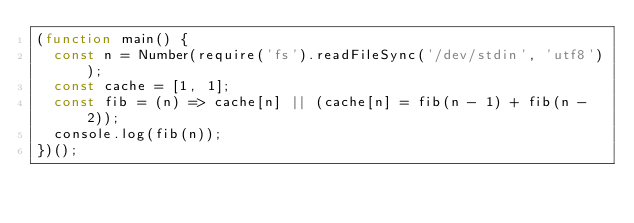Convert code to text. <code><loc_0><loc_0><loc_500><loc_500><_JavaScript_>(function main() {
  const n = Number(require('fs').readFileSync('/dev/stdin', 'utf8'));
  const cache = [1, 1];
  const fib = (n) => cache[n] || (cache[n] = fib(n - 1) + fib(n - 2));
  console.log(fib(n));
})();
</code> 